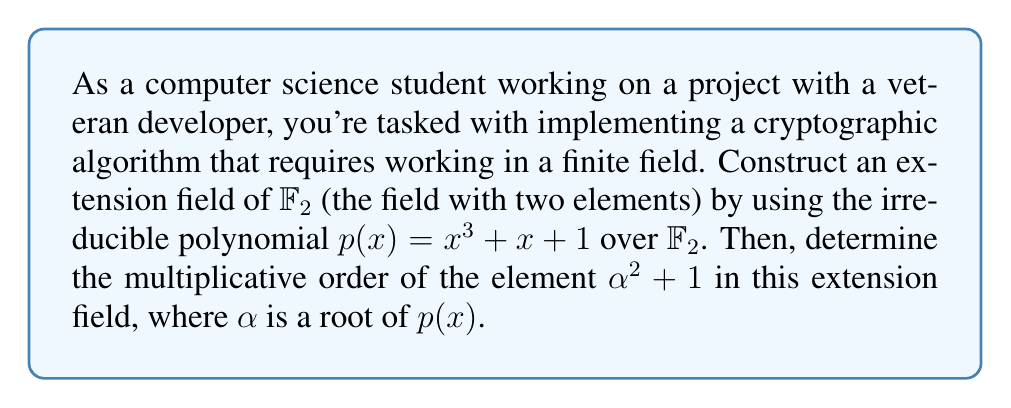Provide a solution to this math problem. 1) First, we construct the extension field $\mathbb{F}_2[x]/(p(x))$, where $p(x) = x^3 + x + 1$. This field has $2^3 = 8$ elements, represented as:

   $\{0, 1, \alpha, \alpha^2, 1+\alpha, 1+\alpha^2, \alpha+\alpha^2, 1+\alpha+\alpha^2\}$

   where $\alpha$ is a root of $p(x)$.

2) We need to find the multiplicative order of $\alpha^2 + 1$. Let's call this element $\beta = \alpha^2 + 1$.

3) To find the order, we compute powers of $\beta$ until we get 1:

   $\beta^1 = \alpha^2 + 1$
   
   $\beta^2 = (\alpha^2 + 1)^2 = \alpha^4 + 1 = \alpha + 1$ (since $\alpha^3 = \alpha + 1$ in this field)
   
   $\beta^3 = (\alpha^2 + 1)(\alpha + 1) = \alpha^3 + \alpha^2 + \alpha + 1 = (\alpha + 1) + \alpha^2 + \alpha + 1 = \alpha^2$
   
   $\beta^4 = (\alpha^2 + 1)\alpha^2 = \alpha^4 + \alpha^2 = (\alpha + 1) + \alpha^2 = \alpha + \alpha^2 + 1$
   
   $\beta^5 = (\alpha^2 + 1)(\alpha + \alpha^2 + 1) = \alpha^3 + \alpha^4 + \alpha^2 + \alpha + \alpha^2 + 1 = (\alpha + 1) + (\alpha + 1) + \alpha + 1 = \alpha$
   
   $\beta^6 = (\alpha^2 + 1)\alpha = \alpha^3 + \alpha = (\alpha + 1) + \alpha = 1$

4) We see that $\beta^6 = 1$, so the multiplicative order of $\alpha^2 + 1$ is 6.
Answer: 6 